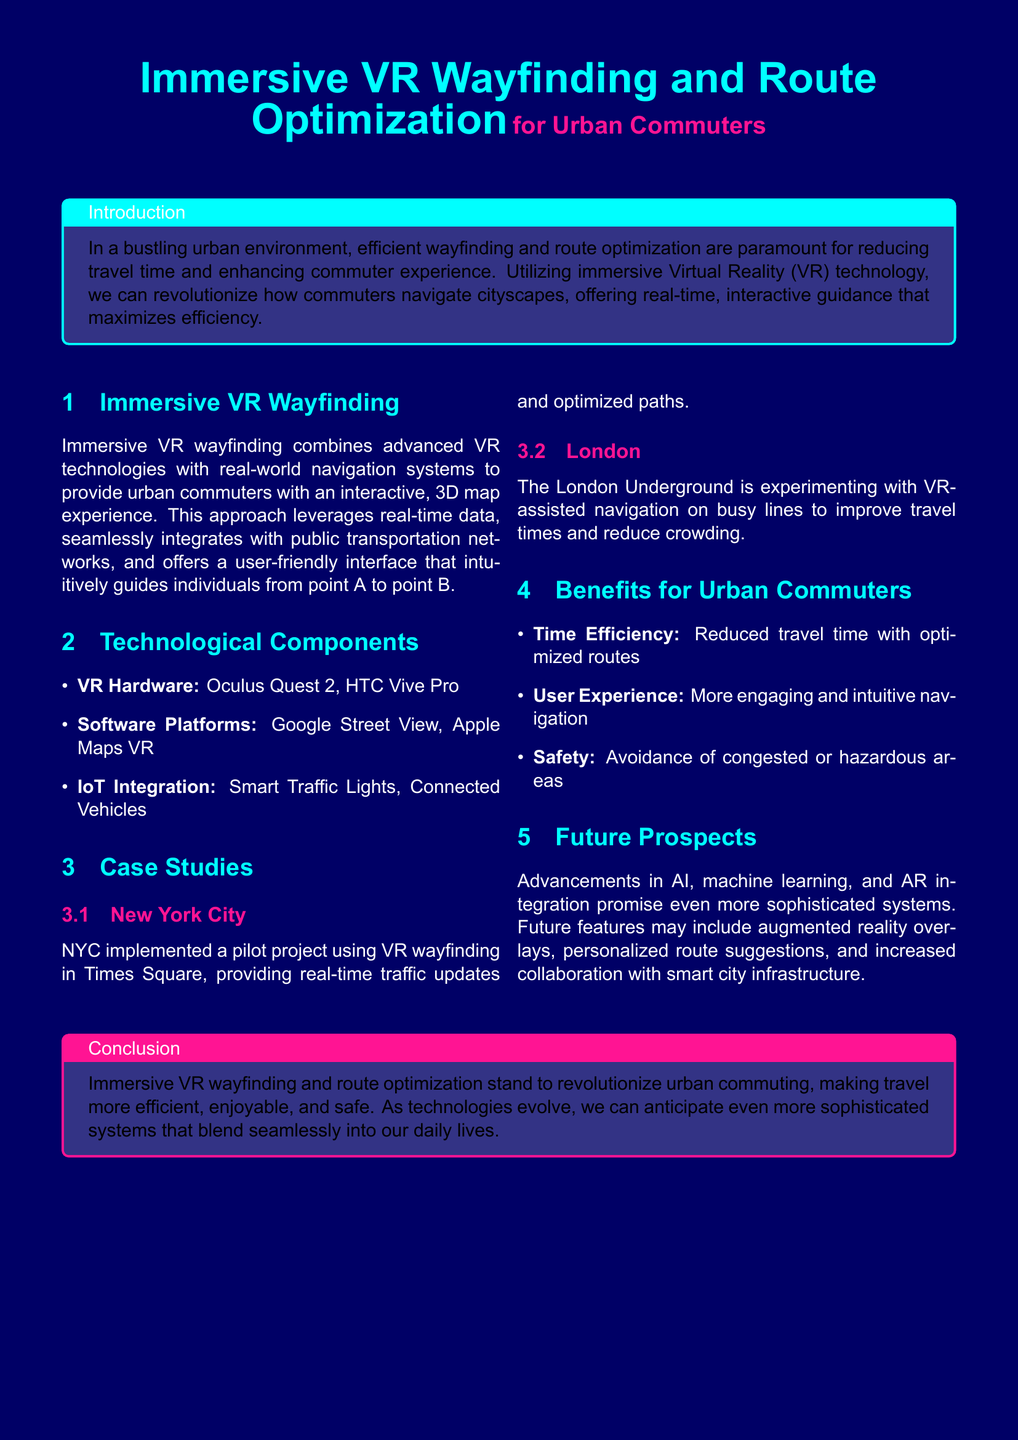what is the title of the document? The title is stated in the header of the document, which emphasizes the subject matter.
Answer: Immersive VR Wayfinding and Route Optimization what city is mentioned for a pilot project? The document describes case studies, one of which includes a pilot project location.
Answer: New York City what hardware is listed in the document? The section on technological components provides specific examples of hardware used in VR applications.
Answer: Oculus Quest 2, HTC Vive Pro what is a benefit for urban commuters mentioned? The document lists several benefits for commuters related to VR wayfinding and route optimization.
Answer: Time Efficiency how does London utilize VR technology? The case study section describes how London is experimenting with VR in a specific context.
Answer: VR-assisted navigation what future technology is anticipated in the document? The future prospects section discusses potential advancements in the field of VR wayfinding.
Answer: Augmented reality overlays how is safety provided according to the document? The benefits section specifically mentions a way that VR wayfinding can enhance safety for users.
Answer: Avoidance of congested or hazardous areas which software platforms are mentioned? The technological components section provides examples of software platforms used in this tech.
Answer: Google Street View, Apple Maps VR 